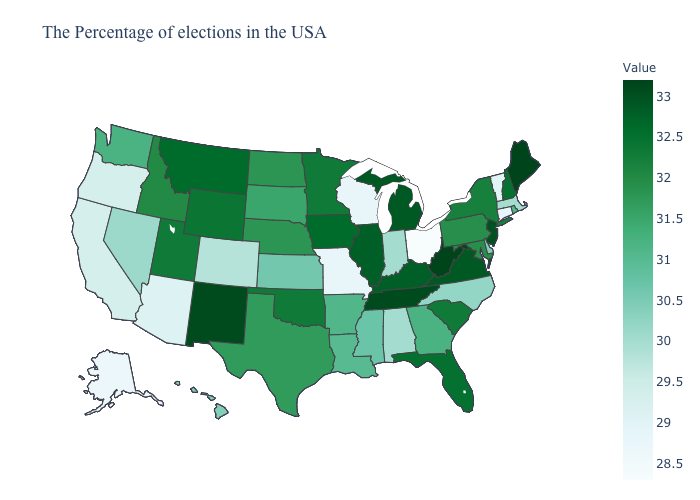Is the legend a continuous bar?
Keep it brief. Yes. Which states have the highest value in the USA?
Answer briefly. Maine, West Virginia. Does Washington have a higher value than Vermont?
Give a very brief answer. Yes. Which states have the lowest value in the USA?
Concise answer only. Ohio. Which states have the highest value in the USA?
Give a very brief answer. Maine, West Virginia. Does Ohio have a lower value than South Carolina?
Keep it brief. Yes. 